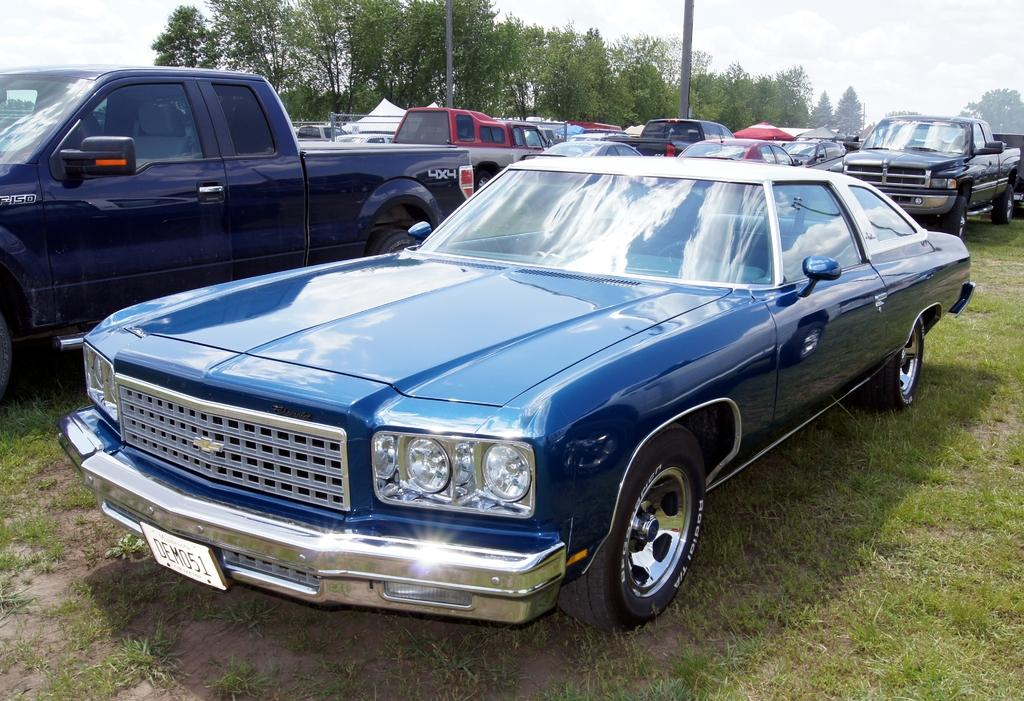What is the unusual location for the vehicles in the image? The vehicles are parked on the grass in the image. What can be seen in the distance behind the vehicles? There are trees and poles in the background of the image. What is visible in the sky in the image? The sky is visible in the background of the image. Where is the mitten located in the image? There is no mitten present in the image. What is the sister doing in the image? There is no sister present in the image. 